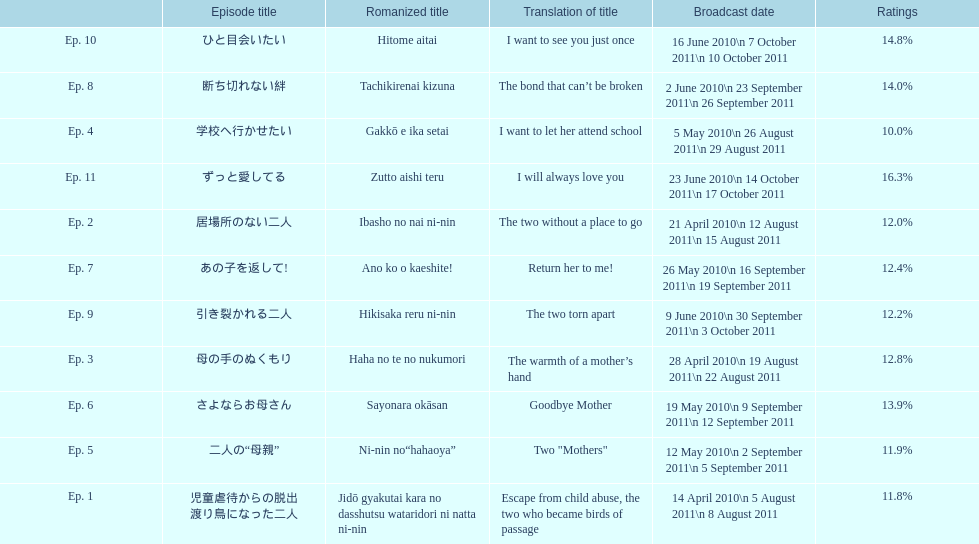How many episodes are there in total? 11. 